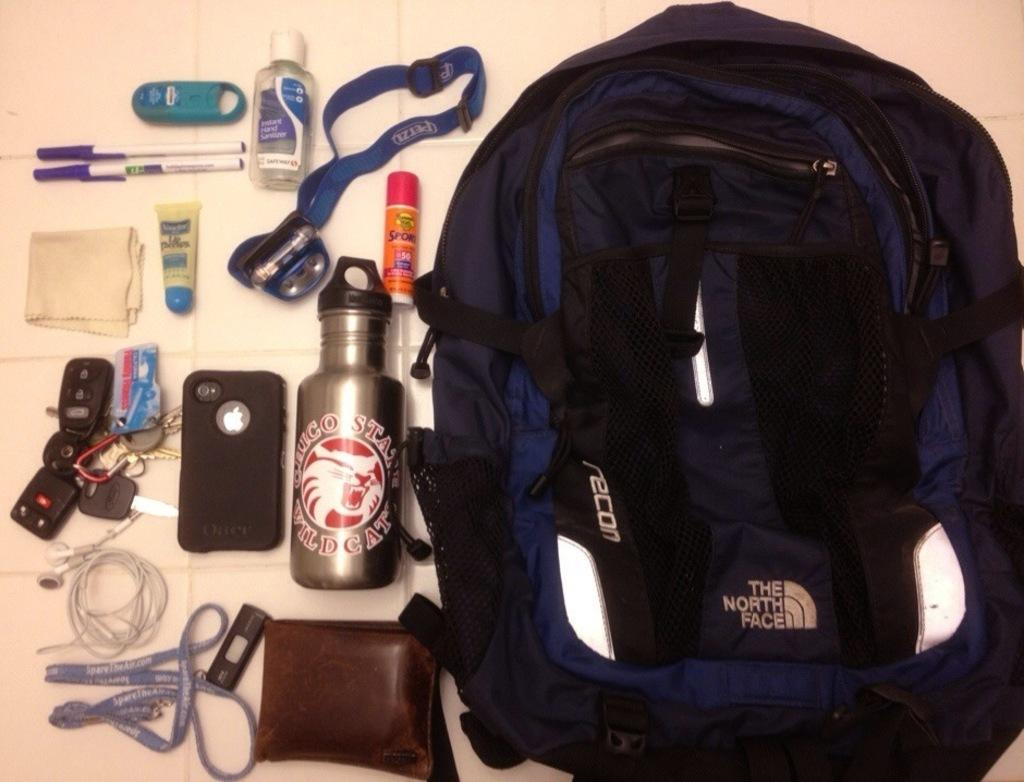What objects are on the table in the image? There is a bag, a bottle, a mobile, a key, a pen, and another bottle on the table in the image. How many bottles are on the table? There are two bottles on the table. What type of object is used for communication in the image? There is a mobile on the table, which is used for communication. What object on the table might be used for writing? The pen on the table might be used for writing. What type of wilderness can be seen in the background of the image? There is no wilderness visible in the image; it only shows objects on a table. 